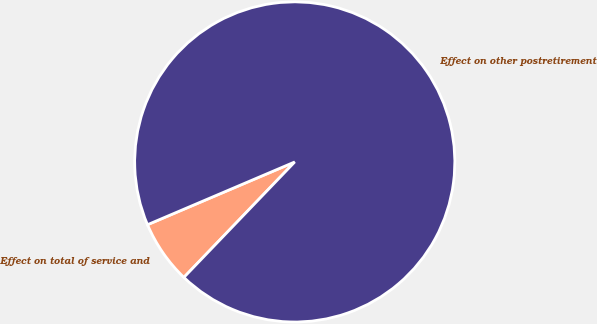<chart> <loc_0><loc_0><loc_500><loc_500><pie_chart><fcel>Effect on total of service and<fcel>Effect on other postretirement<nl><fcel>6.41%<fcel>93.59%<nl></chart> 